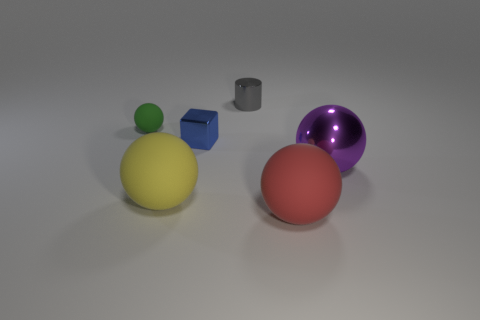Add 1 big shiny spheres. How many objects exist? 7 Subtract all cubes. How many objects are left? 5 Add 1 purple spheres. How many purple spheres are left? 2 Add 4 small balls. How many small balls exist? 5 Subtract 1 green spheres. How many objects are left? 5 Subtract all tiny gray metal objects. Subtract all big rubber spheres. How many objects are left? 3 